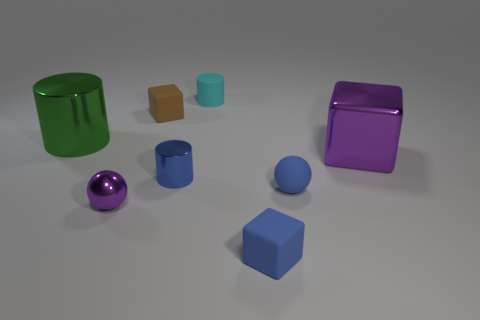Add 1 tiny cyan rubber cylinders. How many objects exist? 9 Subtract all cylinders. How many objects are left? 5 Add 4 big blue things. How many big blue things exist? 4 Subtract 0 cyan spheres. How many objects are left? 8 Subtract all tiny cylinders. Subtract all big metallic cylinders. How many objects are left? 5 Add 6 cyan matte objects. How many cyan matte objects are left? 7 